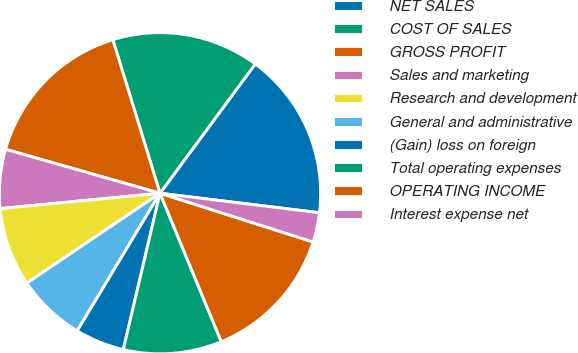<chart> <loc_0><loc_0><loc_500><loc_500><pie_chart><fcel>NET SALES<fcel>COST OF SALES<fcel>GROSS PROFIT<fcel>Sales and marketing<fcel>Research and development<fcel>General and administrative<fcel>(Gain) loss on foreign<fcel>Total operating expenses<fcel>OPERATING INCOME<fcel>Interest expense net<nl><fcel>16.83%<fcel>14.85%<fcel>15.84%<fcel>5.94%<fcel>7.92%<fcel>6.93%<fcel>4.95%<fcel>9.9%<fcel>13.86%<fcel>2.97%<nl></chart> 